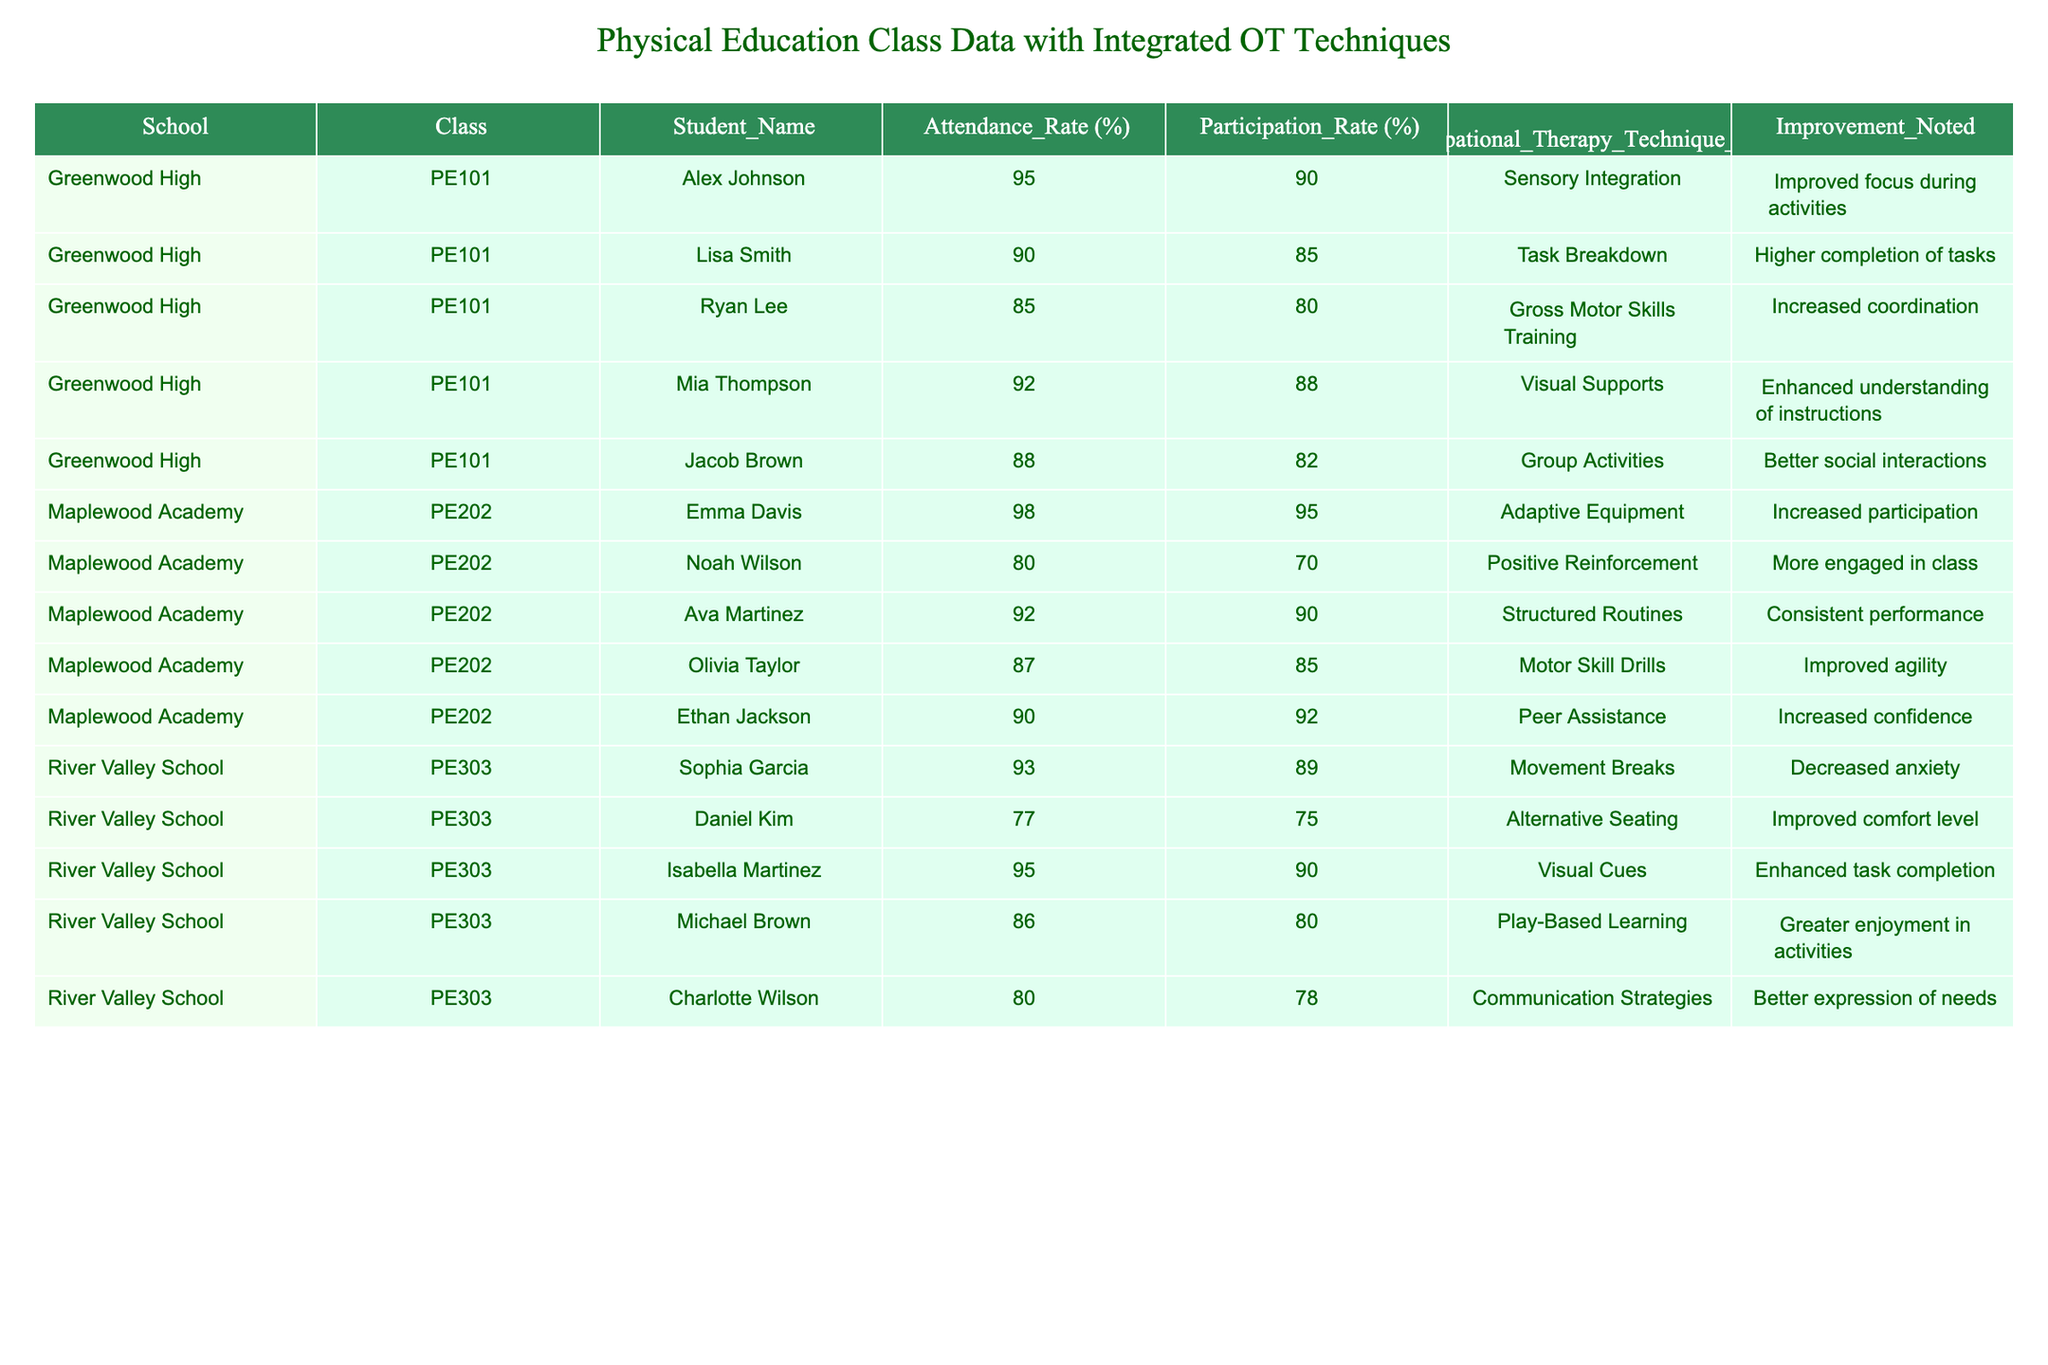What is the attendance rate of Ryan Lee? According to the table, the attendance rate for Ryan Lee is specifically mentioned as 85%.
Answer: 85% Which student had the highest participation rate in their class? The table shows that Emma Davis from Maplewood Academy had the highest participation rate of 95%.
Answer: 95% What is the average attendance rate for the students in PE101? The attendance rates for PE101 are 95, 90, 85, 92, and 88. The sum is 450, and dividing by 5 gives an average of 90.
Answer: 90 Did Olivia Taylor use the Occupational Therapy technique 'Motor Skill Drills'? Looking at the table, it confirms that Olivia Taylor indeed used the 'Motor Skill Drills' technique.
Answer: Yes How many students showed an improvement in physical skills based on the integration of occupational therapy techniques? By reviewing the 'Improvement Noted' column, all students' entries indicate some form of improvement, totaling 15 students across the two classes.
Answer: 15 What is the difference between the participation rates of Noah Wilson and Ethan Jackson? Noah Wilson's participation rate is 70% and Ethan Jackson's is 92%. The difference is 92 - 70 = 22%.
Answer: 22% Which Occupational Therapy technique was used by students with the lowest attendance rates? The students with the lowest attendance rates are Daniel Kim (77%) and Noah Wilson (80%). Both used Alternative Seating and Positive Reinforcement.
Answer: Alternative Seating and Positive Reinforcement What percentage of students in PE202 had an attendance rate above 90%? In PE202, three students (Emma Davis, Ava Martinez, and Ethan Jackson) had attendance rates above 90%, which is 3 out of 5. Thus, the percentage is (3/5) * 100 = 60%.
Answer: 60% Did any students receive 'Improved comfort level' as an improvement note? The table indicates Daniel Kim received 'Improved comfort level' after using Alternative Seating, confirming the fact.
Answer: Yes How does the average participation rate in PE303 compare to the average participation rate in PE101? The average participation rate for PE303 is calculated as (89 + 75 + 90 + 80 + 78) / 5 = 82.4%. For PE101, it's (90 + 85 + 80 + 88 + 82) / 5 = 85%. PE101's participation is higher by 2.6%.
Answer: PE101 is higher by 2.6% 